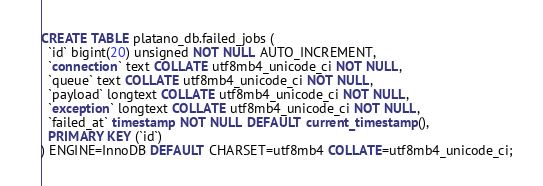<code> <loc_0><loc_0><loc_500><loc_500><_SQL_>CREATE TABLE platano_db.failed_jobs (
  `id` bigint(20) unsigned NOT NULL AUTO_INCREMENT,
  `connection` text COLLATE utf8mb4_unicode_ci NOT NULL,
  `queue` text COLLATE utf8mb4_unicode_ci NOT NULL,
  `payload` longtext COLLATE utf8mb4_unicode_ci NOT NULL,
  `exception` longtext COLLATE utf8mb4_unicode_ci NOT NULL,
  `failed_at` timestamp NOT NULL DEFAULT current_timestamp(),
  PRIMARY KEY (`id`)
) ENGINE=InnoDB DEFAULT CHARSET=utf8mb4 COLLATE=utf8mb4_unicode_ci;
</code> 